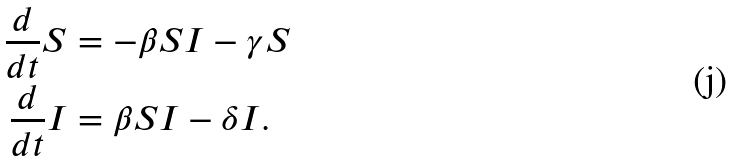<formula> <loc_0><loc_0><loc_500><loc_500>\frac { d } { d t } S & = - \beta S I - \gamma S \\ \frac { d } { d t } I & = \beta S I - \delta I .</formula> 